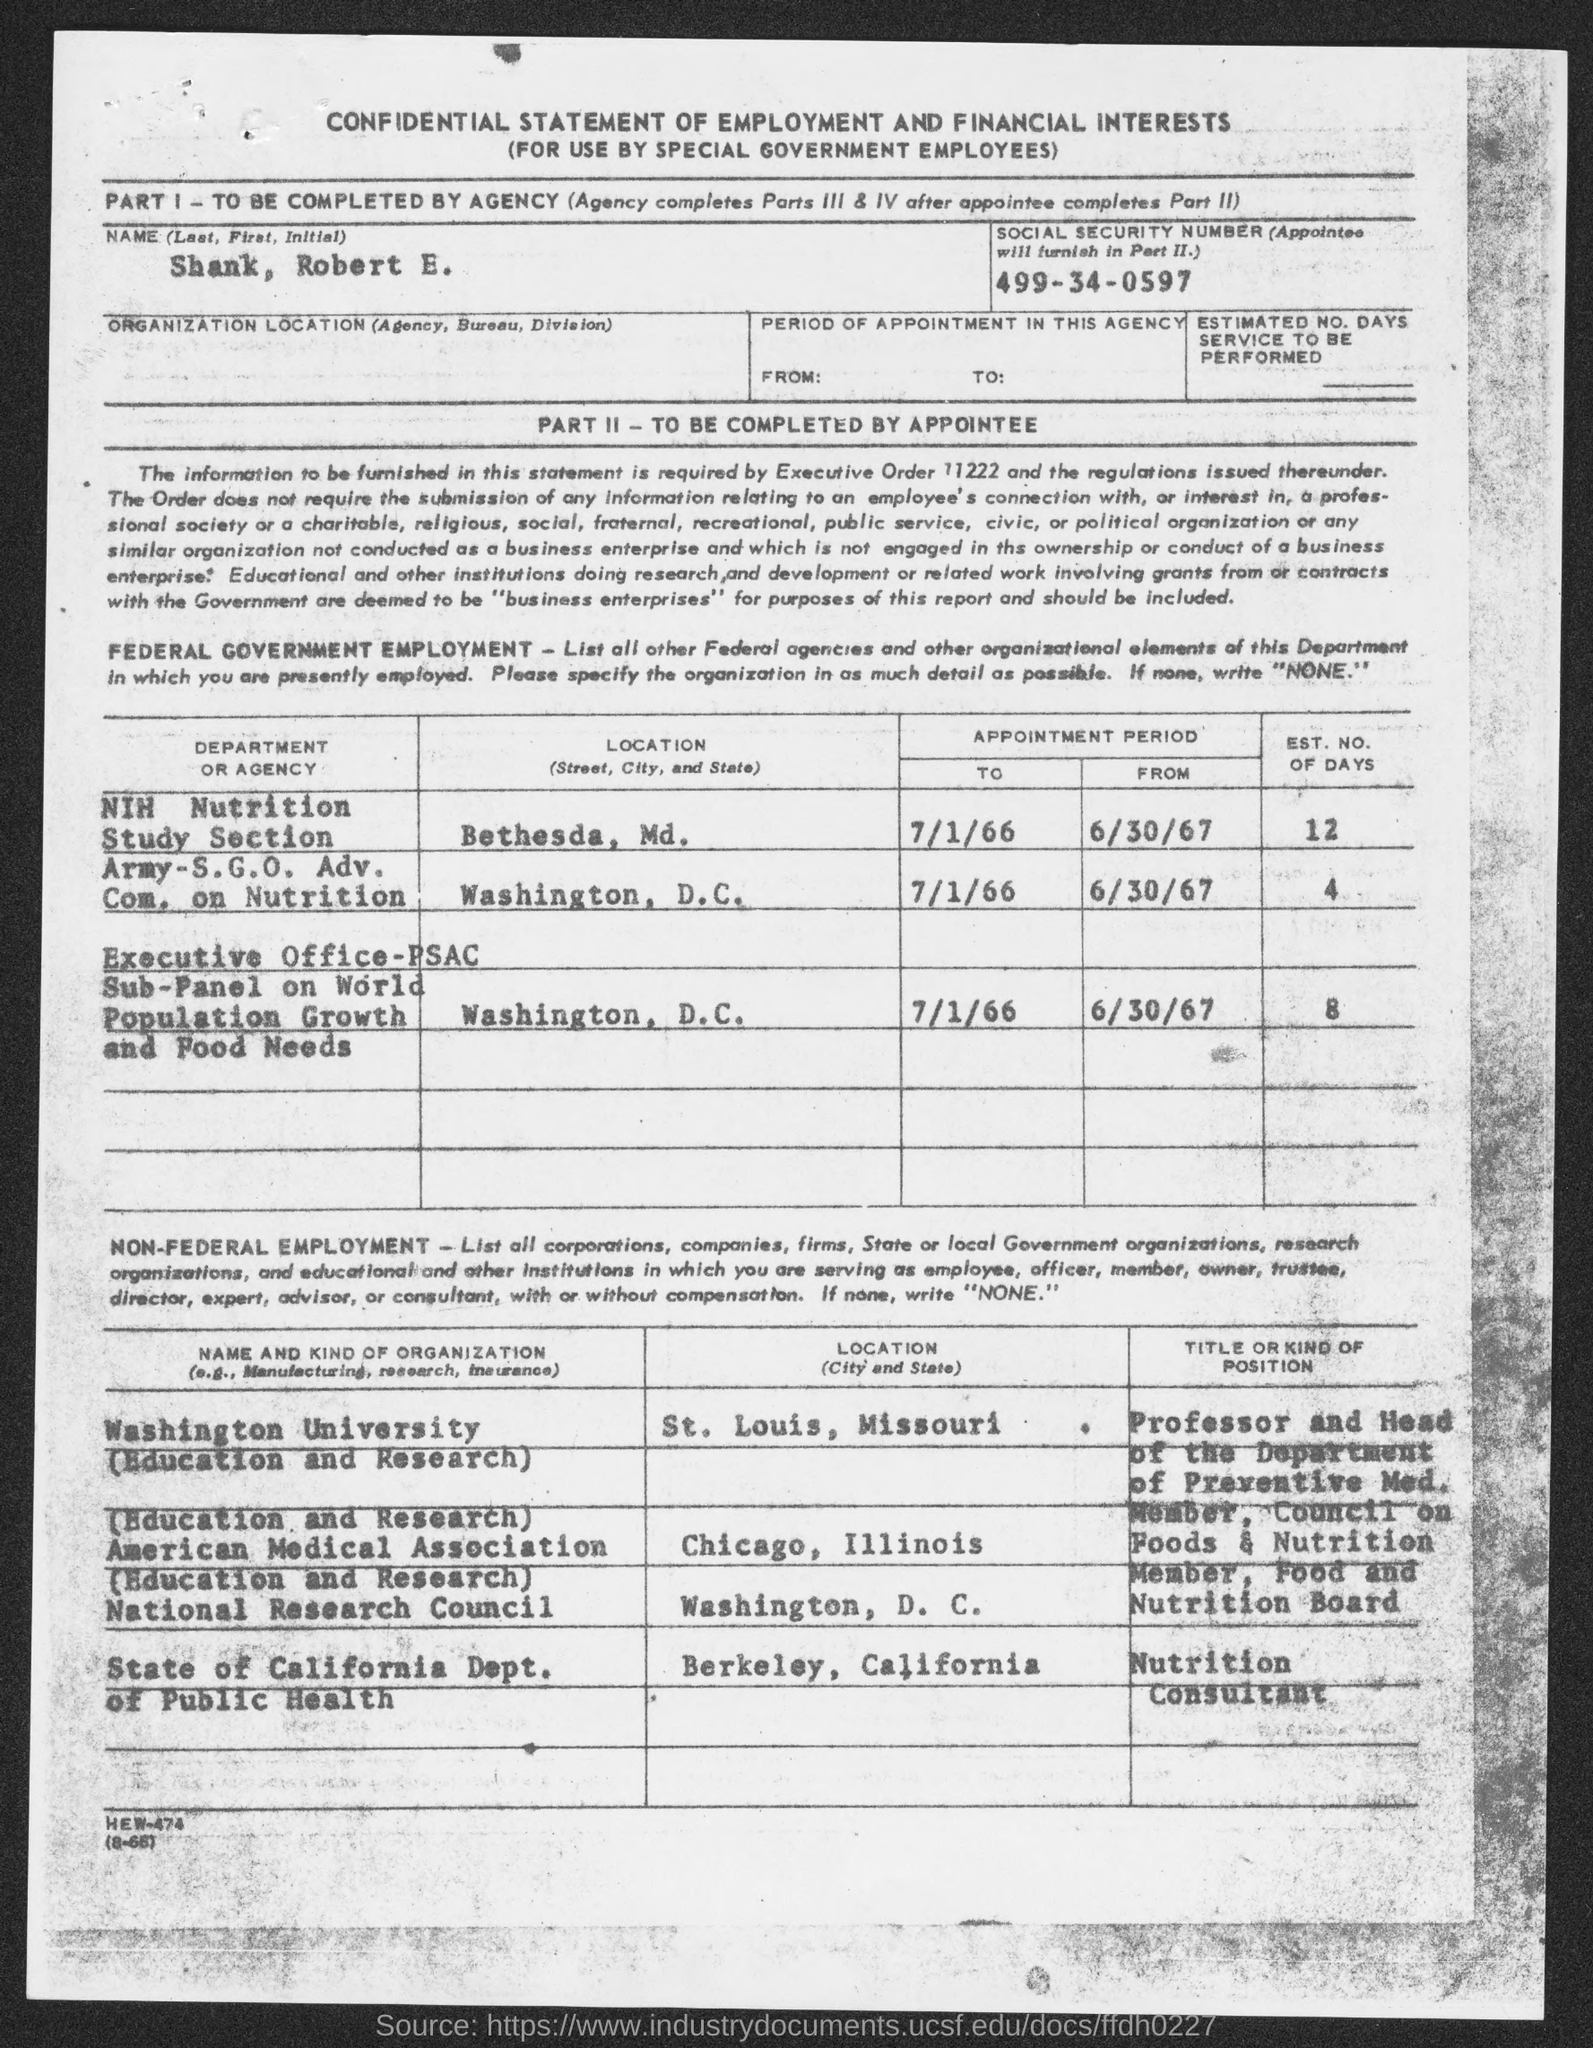Point out several critical features in this image. The name given is Shank, Robert E... The position of Nutrition Consultant is within the Department of Public Health in the State of California, where the primary responsibility is to provide expert advice and guidance on nutrition-related matters. The location of the NIH Nutrition Study Section is in Bethesda, Maryland. The estimated number of days corresponding to population growth and food needs is 8. 